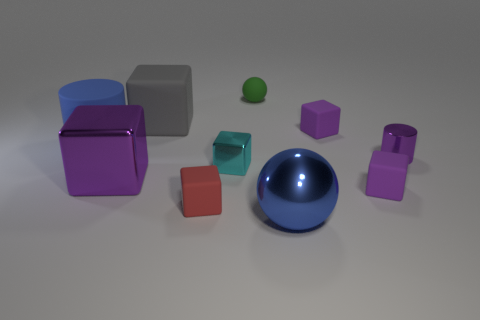Subtract all green spheres. How many purple blocks are left? 3 Subtract all cyan blocks. How many blocks are left? 5 Subtract all big shiny cubes. How many cubes are left? 5 Subtract all gray cubes. Subtract all red cylinders. How many cubes are left? 5 Subtract all cylinders. How many objects are left? 8 Subtract 0 red cylinders. How many objects are left? 10 Subtract all brown cylinders. Subtract all small green matte spheres. How many objects are left? 9 Add 2 big purple metallic objects. How many big purple metallic objects are left? 3 Add 9 brown cylinders. How many brown cylinders exist? 9 